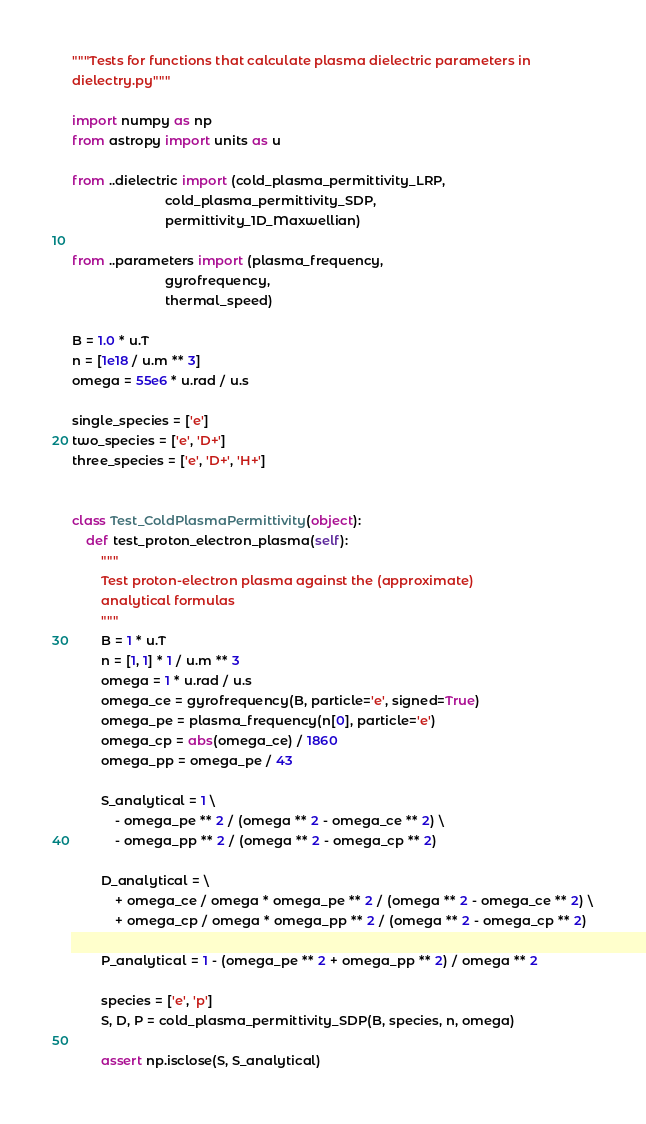<code> <loc_0><loc_0><loc_500><loc_500><_Python_>"""Tests for functions that calculate plasma dielectric parameters in
dielectry.py"""

import numpy as np
from astropy import units as u

from ..dielectric import (cold_plasma_permittivity_LRP,
                          cold_plasma_permittivity_SDP,
                          permittivity_1D_Maxwellian)

from ..parameters import (plasma_frequency,
                          gyrofrequency,
                          thermal_speed)

B = 1.0 * u.T
n = [1e18 / u.m ** 3]
omega = 55e6 * u.rad / u.s

single_species = ['e']
two_species = ['e', 'D+']
three_species = ['e', 'D+', 'H+']


class Test_ColdPlasmaPermittivity(object):
    def test_proton_electron_plasma(self):
        """
        Test proton-electron plasma against the (approximate)
        analytical formulas
        """
        B = 1 * u.T
        n = [1, 1] * 1 / u.m ** 3
        omega = 1 * u.rad / u.s
        omega_ce = gyrofrequency(B, particle='e', signed=True)
        omega_pe = plasma_frequency(n[0], particle='e')
        omega_cp = abs(omega_ce) / 1860
        omega_pp = omega_pe / 43

        S_analytical = 1 \
            - omega_pe ** 2 / (omega ** 2 - omega_ce ** 2) \
            - omega_pp ** 2 / (omega ** 2 - omega_cp ** 2)

        D_analytical = \
            + omega_ce / omega * omega_pe ** 2 / (omega ** 2 - omega_ce ** 2) \
            + omega_cp / omega * omega_pp ** 2 / (omega ** 2 - omega_cp ** 2)

        P_analytical = 1 - (omega_pe ** 2 + omega_pp ** 2) / omega ** 2

        species = ['e', 'p']
        S, D, P = cold_plasma_permittivity_SDP(B, species, n, omega)

        assert np.isclose(S, S_analytical)</code> 